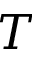Convert formula to latex. <formula><loc_0><loc_0><loc_500><loc_500>T</formula> 